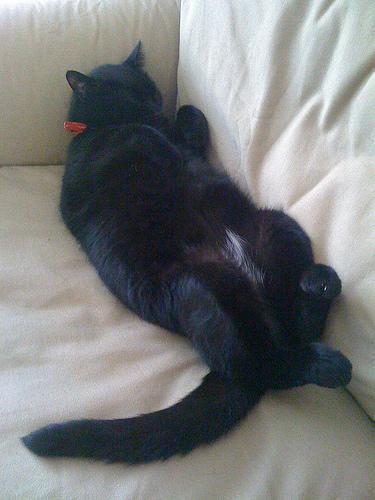How many cats are shown?
Give a very brief answer. 1. 